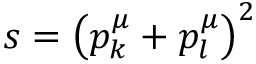<formula> <loc_0><loc_0><loc_500><loc_500>s = \left ( p _ { k } ^ { \mu } + p _ { l } ^ { \mu } \right ) ^ { 2 }</formula> 